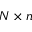Convert formula to latex. <formula><loc_0><loc_0><loc_500><loc_500>N \times n</formula> 